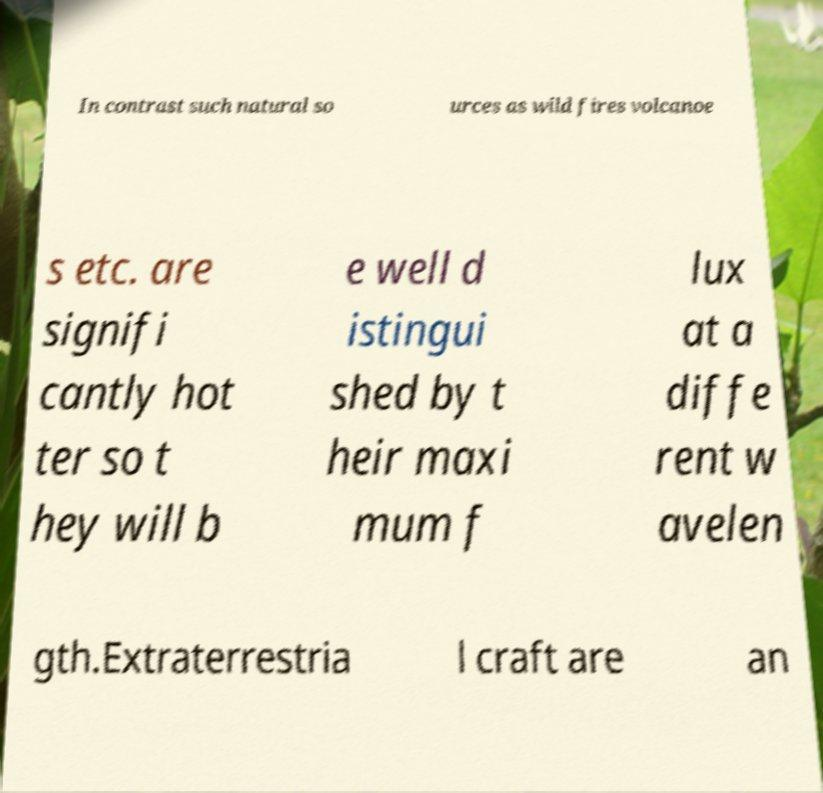For documentation purposes, I need the text within this image transcribed. Could you provide that? In contrast such natural so urces as wild fires volcanoe s etc. are signifi cantly hot ter so t hey will b e well d istingui shed by t heir maxi mum f lux at a diffe rent w avelen gth.Extraterrestria l craft are an 